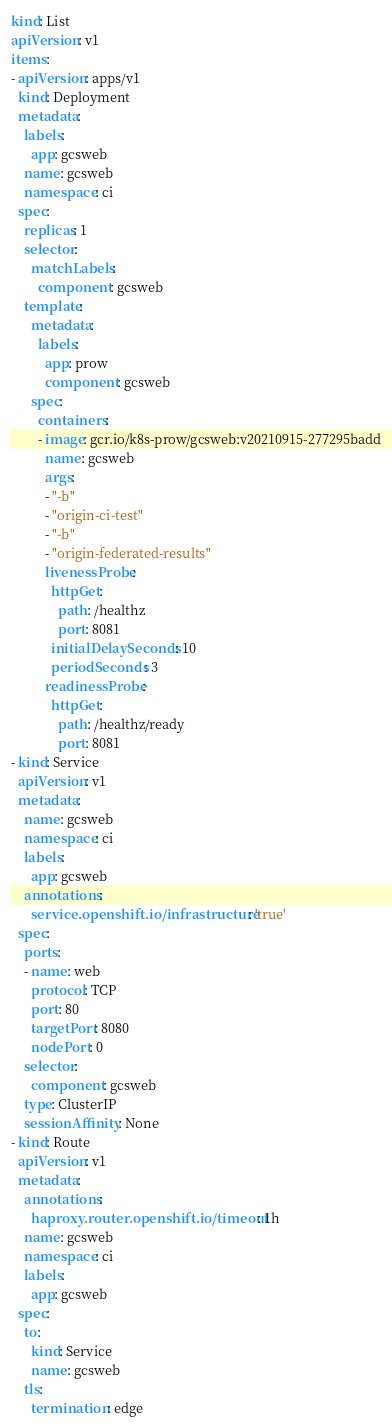Convert code to text. <code><loc_0><loc_0><loc_500><loc_500><_YAML_>kind: List
apiVersion: v1
items:
- apiVersion: apps/v1
  kind: Deployment
  metadata:
    labels:
      app: gcsweb
    name: gcsweb
    namespace: ci
  spec:
    replicas: 1
    selector:
      matchLabels:
        component: gcsweb
    template:
      metadata:
        labels:
          app: prow
          component: gcsweb
      spec:
        containers:
        - image: gcr.io/k8s-prow/gcsweb:v20210915-277295badd
          name: gcsweb
          args:
          - "-b"
          - "origin-ci-test"
          - "-b"
          - "origin-federated-results"
          livenessProbe:
            httpGet:
              path: /healthz
              port: 8081
            initialDelaySeconds: 10
            periodSeconds: 3
          readinessProbe:
            httpGet:
              path: /healthz/ready
              port: 8081
- kind: Service
  apiVersion: v1
  metadata:
    name: gcsweb
    namespace: ci
    labels:
      app: gcsweb
    annotations:
      service.openshift.io/infrastructure: 'true'
  spec:
    ports:
    - name: web
      protocol: TCP
      port: 80
      targetPort: 8080
      nodePort: 0
    selector:
      component: gcsweb
    type: ClusterIP
    sessionAffinity: None
- kind: Route
  apiVersion: v1
  metadata:
    annotations:
      haproxy.router.openshift.io/timeout: 1h
    name: gcsweb
    namespace: ci
    labels:
      app: gcsweb
  spec:
    to:
      kind: Service
      name: gcsweb
    tls:
      termination: edge</code> 